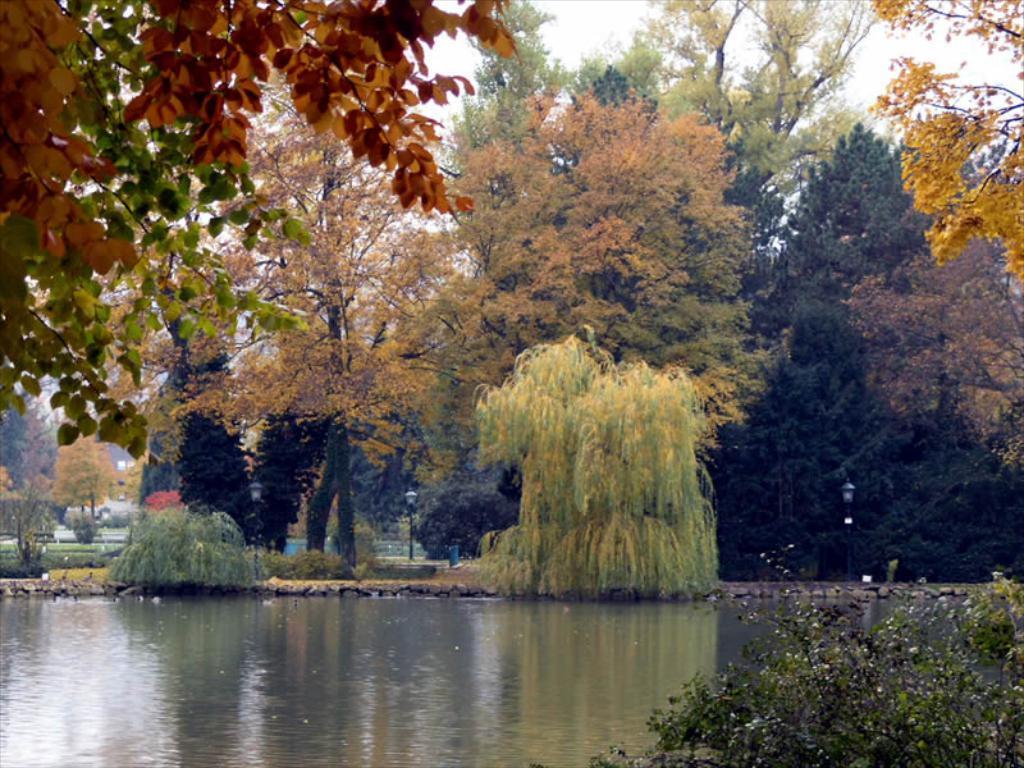Describe this image in one or two sentences. In this image I can see the water. To the side of the water I can see the plants, poles and many trees. In the background I can see the sky. 